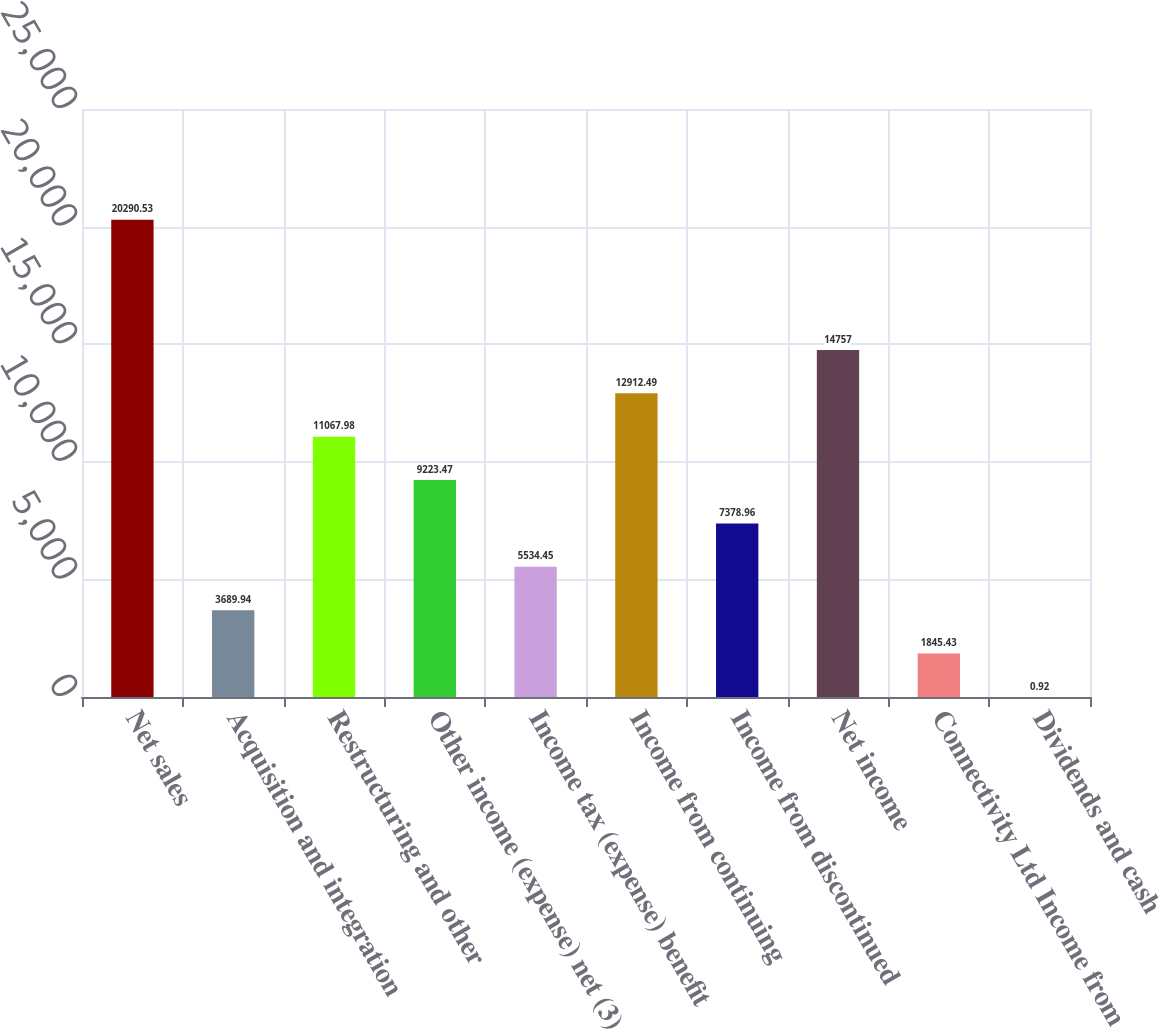Convert chart to OTSL. <chart><loc_0><loc_0><loc_500><loc_500><bar_chart><fcel>Net sales<fcel>Acquisition and integration<fcel>Restructuring and other<fcel>Other income (expense) net (3)<fcel>Income tax (expense) benefit<fcel>Income from continuing<fcel>Income from discontinued<fcel>Net income<fcel>Connectivity Ltd Income from<fcel>Dividends and cash<nl><fcel>20290.5<fcel>3689.94<fcel>11068<fcel>9223.47<fcel>5534.45<fcel>12912.5<fcel>7378.96<fcel>14757<fcel>1845.43<fcel>0.92<nl></chart> 